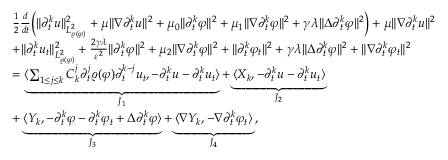Convert formula to latex. <formula><loc_0><loc_0><loc_500><loc_500>\begin{array} { r l } & { \frac { 1 } { 2 } \frac { d } { d t } \left ( \| \partial _ { t } ^ { k } u \| _ { L _ { \varrho ( \varphi ) } ^ { 2 } } ^ { 2 } + \mu \| \nabla \partial _ { t } ^ { k } u \| ^ { 2 } + \mu _ { 0 } \| \partial _ { t } ^ { k } \varphi \| ^ { 2 } + \mu _ { 1 } \| \nabla \partial _ { t } ^ { k } \varphi \| ^ { 2 } + \gamma \lambda \| \Delta \partial _ { t } ^ { k } \varphi \| ^ { 2 } \right ) + \mu \| \nabla \partial _ { t } ^ { k } u \| ^ { 2 } } \\ & { + \| \partial _ { t } ^ { k } u _ { t } \| _ { L _ { \varrho ( \varphi ) } ^ { 2 } } ^ { 2 } + \frac { 2 \gamma \lambda } { \varepsilon ^ { 2 } } \| \partial _ { t } ^ { k } \varphi \| ^ { 2 } + \mu _ { 2 } \| \nabla \partial _ { t } ^ { k } \varphi \| ^ { 2 } + \| \partial _ { t } ^ { k } \varphi _ { t } \| ^ { 2 } + \gamma \lambda \| \Delta \partial _ { t } ^ { k } \varphi \| ^ { 2 } + \| \nabla \partial _ { t } ^ { k } \varphi _ { t } \| ^ { 2 } } \\ & { = \underbrace { \langle \sum _ { 1 \leq j \leq k } C _ { k } ^ { j } \partial _ { t } ^ { j } \varrho ( \varphi ) \partial _ { t } ^ { k - j } u _ { t } , - \partial _ { t } ^ { k } u - \partial _ { t } ^ { k } u _ { t } \rangle } _ { J _ { 1 } } + \underbrace { \langle X _ { k } , - \partial _ { t } ^ { k } u - \partial _ { t } ^ { k } u _ { t } \rangle } _ { J _ { 2 } } } \\ & { + \underbrace { \langle Y _ { k } , - \partial _ { t } ^ { k } \varphi - \partial _ { t } ^ { k } \varphi _ { t } + \Delta \partial _ { t } ^ { k } \varphi \rangle } _ { J _ { 3 } } + \underbrace { \langle \nabla Y _ { k } , - \nabla \partial _ { t } ^ { k } \varphi _ { t } \rangle } _ { J _ { 4 } } \, , } \end{array}</formula> 